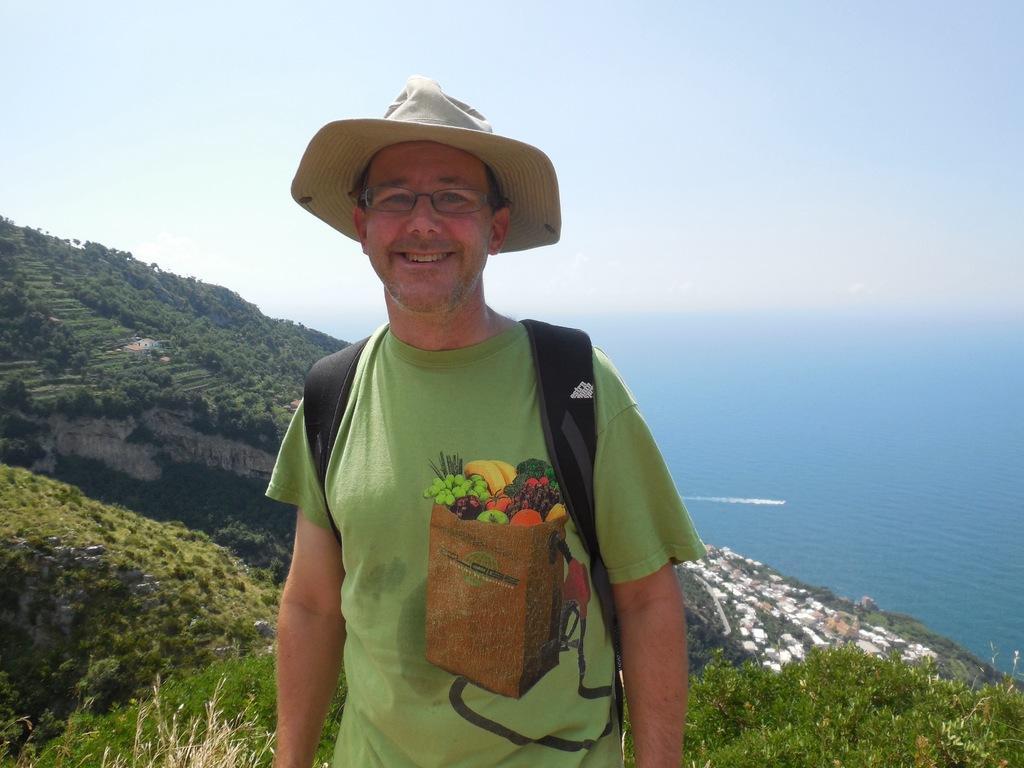Can you describe this image briefly? In this picture I can see there is a man standing and he is wearing a bag, shirt, hat and spectacles and there is an ocean at right side and there is a mountain in the backdrop and it is covered with trees and there are few buildings on the right side and the sky is clear. 